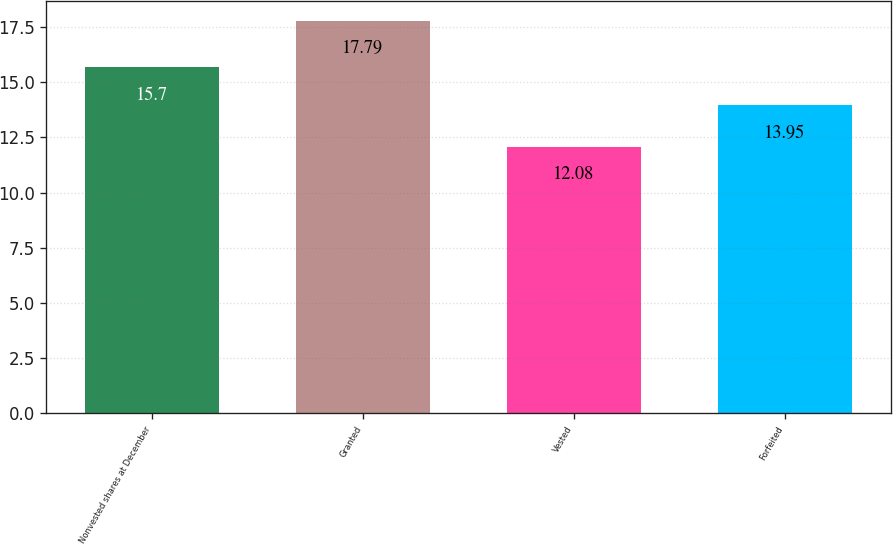Convert chart. <chart><loc_0><loc_0><loc_500><loc_500><bar_chart><fcel>Nonvested shares at December<fcel>Granted<fcel>Vested<fcel>Forfeited<nl><fcel>15.7<fcel>17.79<fcel>12.08<fcel>13.95<nl></chart> 